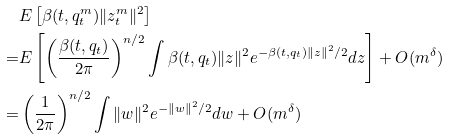Convert formula to latex. <formula><loc_0><loc_0><loc_500><loc_500>& E \left [ \beta ( t , q _ { t } ^ { m } ) \| z _ { t } ^ { m } \| ^ { 2 } \right ] \\ = & E \left [ \left ( \frac { \beta ( t , q _ { t } ) } { 2 \pi } \right ) ^ { n / 2 } \int \beta ( t , q _ { t } ) \| z \| ^ { 2 } e ^ { - \beta ( t , q _ { t } ) \| z \| ^ { 2 } / 2 } d z \right ] + O ( m ^ { \delta } ) \\ = & \left ( \frac { 1 } { 2 \pi } \right ) ^ { n / 2 } \int \| w \| ^ { 2 } e ^ { - \| w \| ^ { 2 } / 2 } d w + O ( m ^ { \delta } )</formula> 